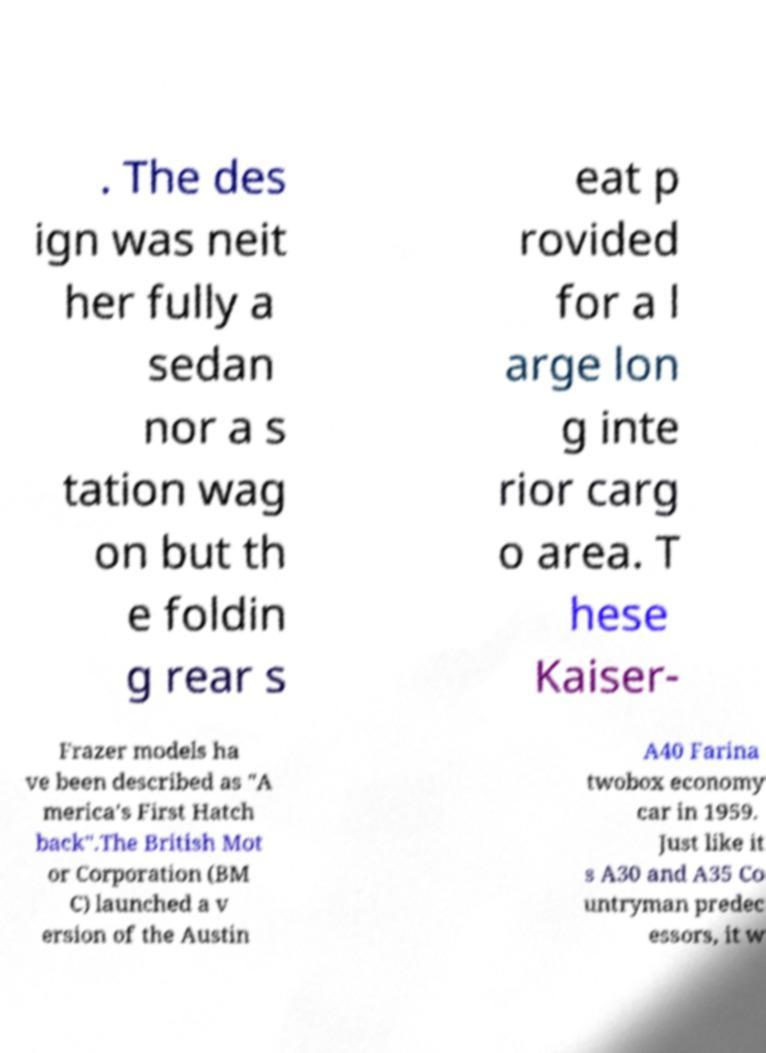What messages or text are displayed in this image? I need them in a readable, typed format. . The des ign was neit her fully a sedan nor a s tation wag on but th e foldin g rear s eat p rovided for a l arge lon g inte rior carg o area. T hese Kaiser- Frazer models ha ve been described as "A merica’s First Hatch back".The British Mot or Corporation (BM C) launched a v ersion of the Austin A40 Farina twobox economy car in 1959. Just like it s A30 and A35 Co untryman predec essors, it w 